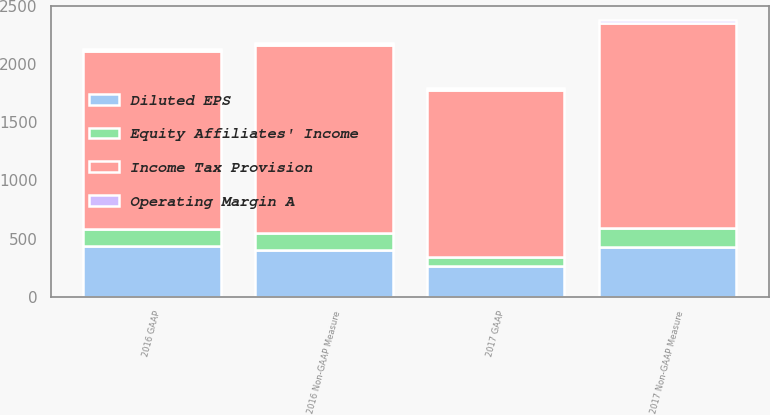Convert chart. <chart><loc_0><loc_0><loc_500><loc_500><stacked_bar_chart><ecel><fcel>2017 GAAP<fcel>2016 GAAP<fcel>2017 Non-GAAP Measure<fcel>2016 Non-GAAP Measure<nl><fcel>Income Tax Provision<fcel>1440<fcel>1535.1<fcel>1773.8<fcel>1620.2<nl><fcel>Operating Margin A<fcel>17.6<fcel>20.5<fcel>21.7<fcel>21.6<nl><fcel>Equity Affiliates' Income<fcel>80.1<fcel>147<fcel>159.6<fcel>147<nl><fcel>Diluted EPS<fcel>260.9<fcel>432.6<fcel>427<fcel>398.9<nl></chart> 